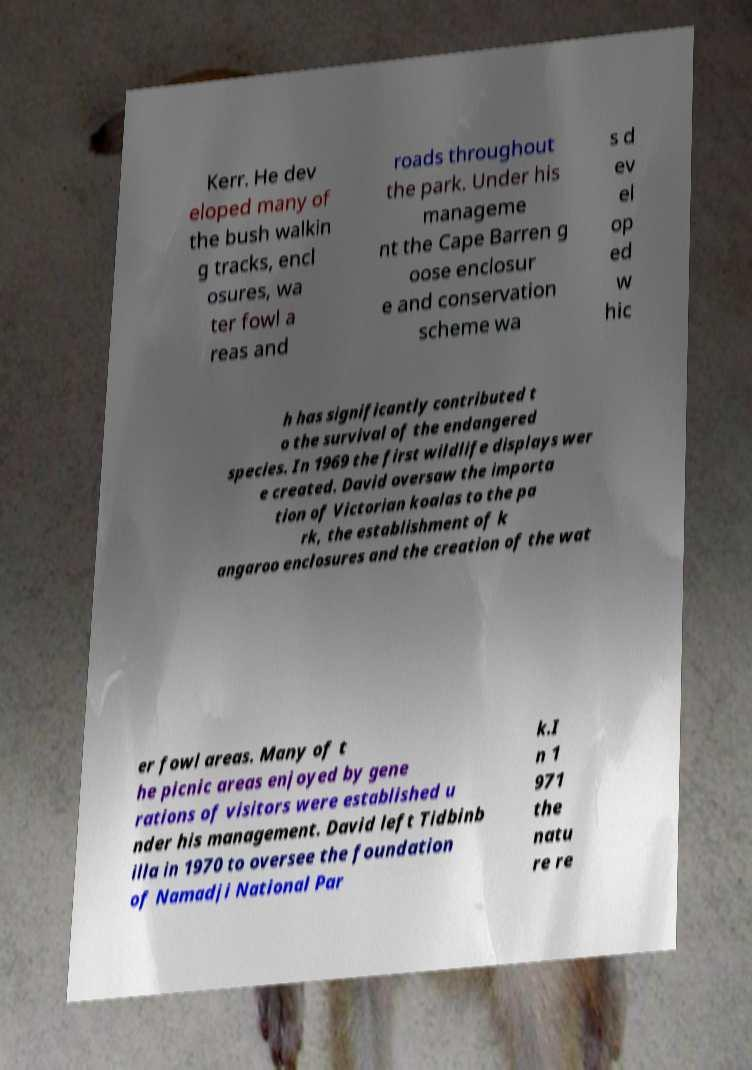Could you extract and type out the text from this image? Kerr. He dev eloped many of the bush walkin g tracks, encl osures, wa ter fowl a reas and roads throughout the park. Under his manageme nt the Cape Barren g oose enclosur e and conservation scheme wa s d ev el op ed w hic h has significantly contributed t o the survival of the endangered species. In 1969 the first wildlife displays wer e created. David oversaw the importa tion of Victorian koalas to the pa rk, the establishment of k angaroo enclosures and the creation of the wat er fowl areas. Many of t he picnic areas enjoyed by gene rations of visitors were established u nder his management. David left Tidbinb illa in 1970 to oversee the foundation of Namadji National Par k.I n 1 971 the natu re re 